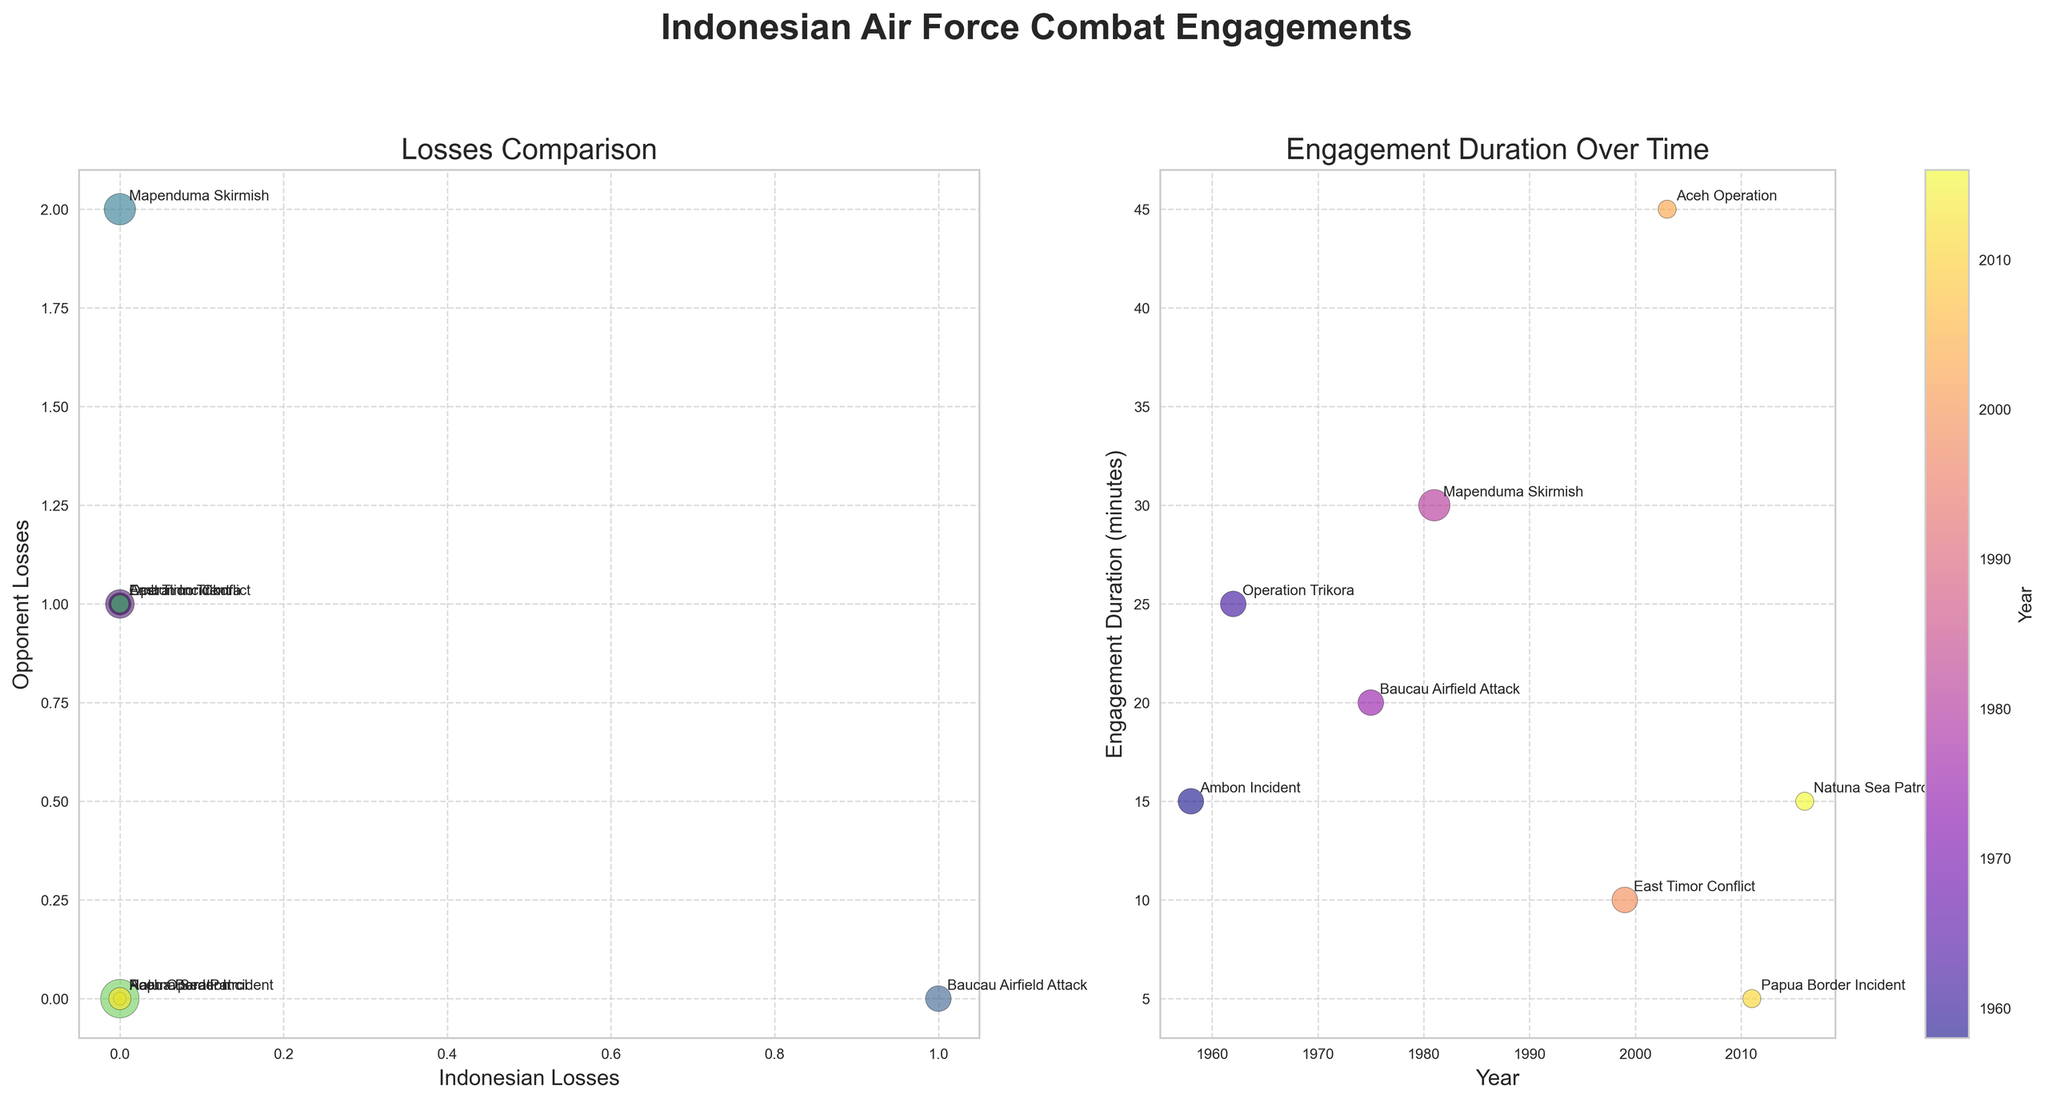What is the title of the first bubble chart? The first chart is labeled as "Losses Comparison." You can see the title at the top of the chart.
Answer: Losses Comparison Which engagement took place in 2016, and how long did it last? Referring to the second bubble chart, the engagement labeled "Natuna Sea Patrol" occurred in 2016 and it lasted for 15 minutes, as shown by the bubble's annotations.
Answer: Natuna Sea Patrol, 15 minutes Compare the losses in the Ambon Incident and the Baucau Airfield Attack. Which engagement saw more Indonesian losses? The Ambon Incident recorded 0 Indonesian losses, whereas the Baucau Airfield Attack recorded 1 Indonesian loss. Therefore, the Baucau Airfield Attack saw more Indonesian losses.
Answer: Baucau Airfield Attack Which engagement had the longest duration, and how many losses occurred in that engagement? By examining the second bubble chart, the engagement named "Aceh Operation" lasted the longest at 45 minutes, and it experienced 0 Indonesian losses and 0 opponent losses as indicated by the size and annotation of the bubble.
Answer: Aceh Operation, 0 losses Determine the average engagement duration across all recorded engagements. Adding up all the engagement durations: 15 + 25 + 20 + 30 + 10 + 45 + 5 + 15 = 165 minutes, divided by the 8 engagements, gives an average duration of 165/8 = 20.625 minutes.
Answer: 20.625 minutes How did the Indonesian Air Force engage in terms of losses during the Papua Border Incident in 2011? In the first bubble chart under the "Papua Border Incident," it shows both the Indonesian and opponent losses were 0, as indicated by the size and position of the bubble on both axes.
Answer: 0 Indonesian losses, 0 opponent losses Which engagement between 1958 and 1981 caused the most losses to the opponent? From the first chart, the "Mapenduma Skirmish" in 1981 caused the opponent the most losses with a count of 2, as indicated by the largest value on the "Opponent Losses" axis.
Answer: Mapenduma Skirmish How are the engagement bubbles visually distinguished based on the year in both charts? The bubbles are color-coded based on the year of the engagement, with the first chart using a 'viridis' colormap and the second using a 'plasma' colormap, allowing viewers to easily compare and track engagements across different years.
Answer: By colors What is the shortest engagement duration? The second bubble chart indicates that the "Papua Border Incident" in 2011 had the shortest engagement duration of 5 minutes, as noted by the annotations.
Answer: Papua Border Incident, 5 minutes In which engagement did the Indonesian Air Force lose an A-26 Invader aircraft? The first bubble chart shows an Indonesian loss of 1 in the "Baucau Airfield Attack" engagement, and this correlates with the data provided about the loss of an A-26 Invader.
Answer: Baucau Airfield Attack 